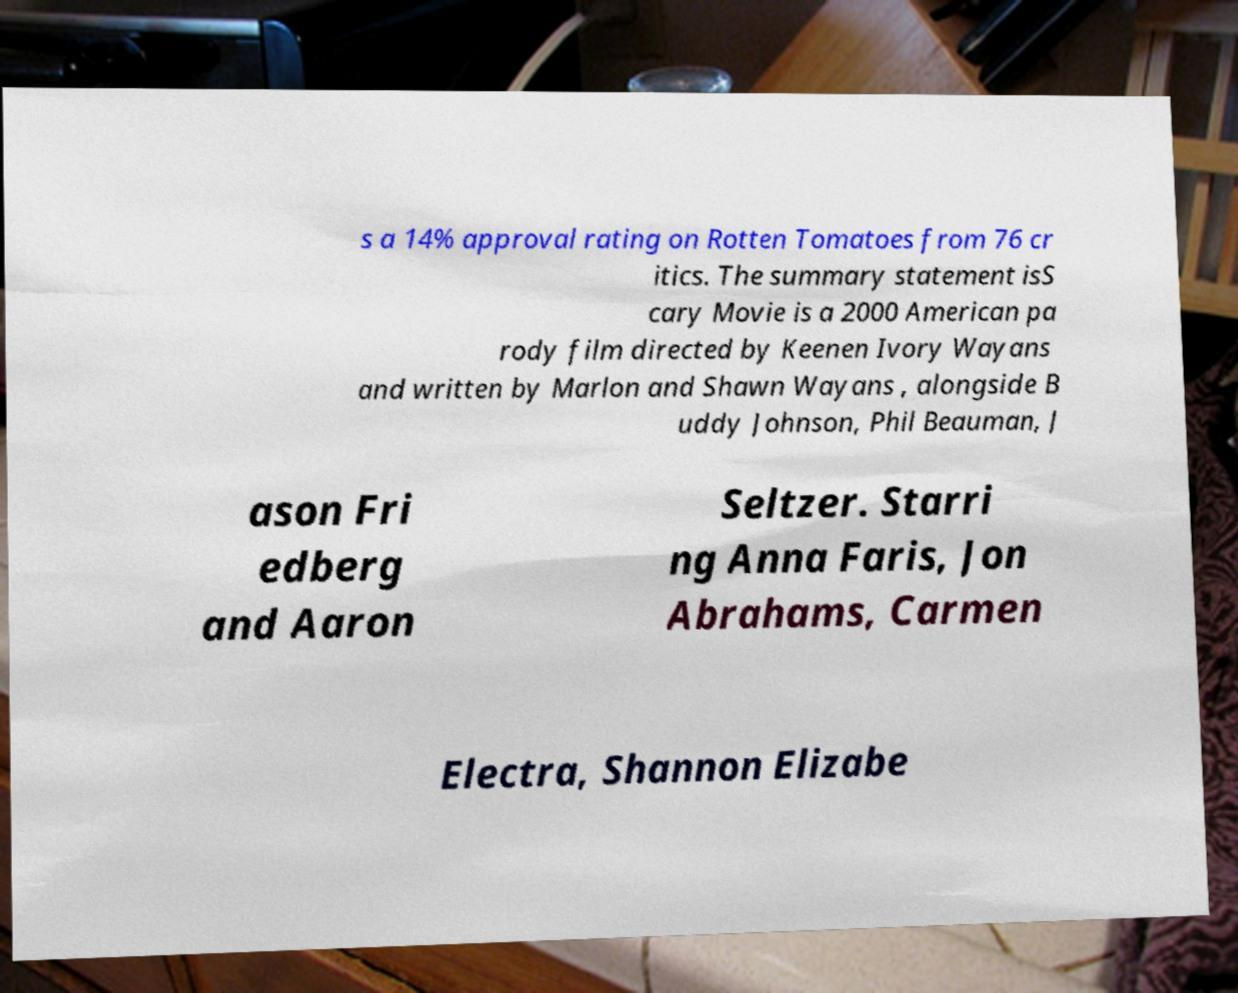There's text embedded in this image that I need extracted. Can you transcribe it verbatim? s a 14% approval rating on Rotten Tomatoes from 76 cr itics. The summary statement isS cary Movie is a 2000 American pa rody film directed by Keenen Ivory Wayans and written by Marlon and Shawn Wayans , alongside B uddy Johnson, Phil Beauman, J ason Fri edberg and Aaron Seltzer. Starri ng Anna Faris, Jon Abrahams, Carmen Electra, Shannon Elizabe 